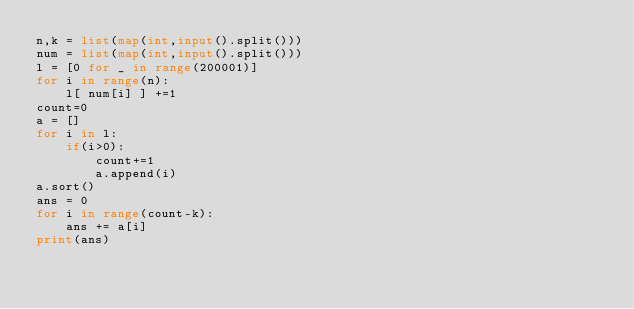Convert code to text. <code><loc_0><loc_0><loc_500><loc_500><_Python_>n,k = list(map(int,input().split()))
num = list(map(int,input().split()))
l = [0 for _ in range(200001)]
for i in range(n):
    l[ num[i] ] +=1
count=0
a = []
for i in l:
    if(i>0):
        count+=1
        a.append(i)
a.sort()
ans = 0
for i in range(count-k):
    ans += a[i]
print(ans)</code> 